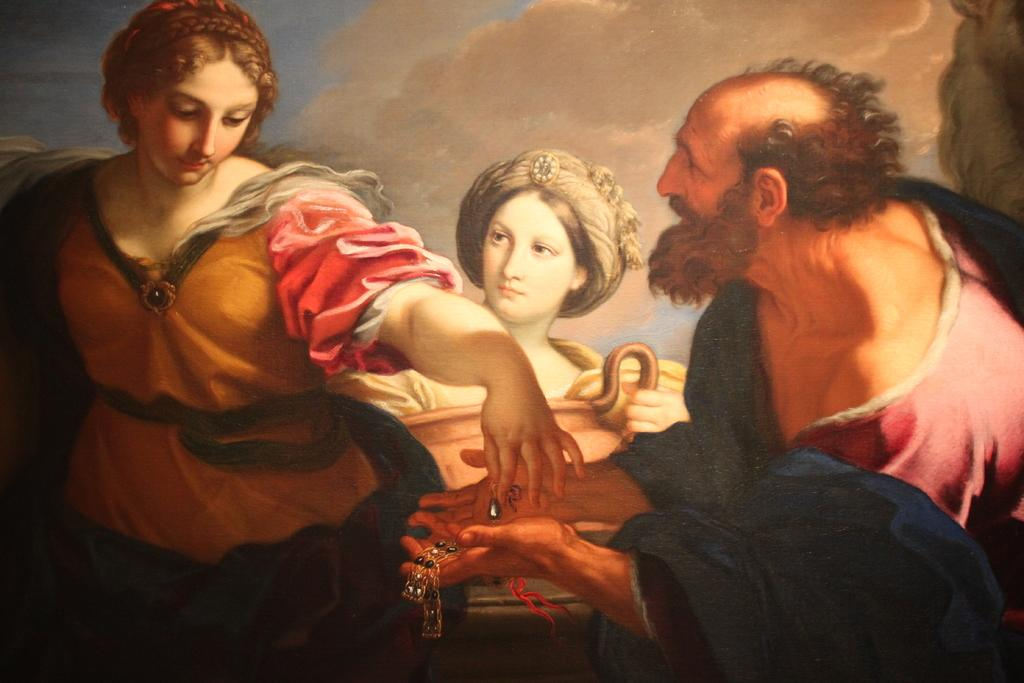Who or what can be seen in the image? There are people in the image. What part of the natural environment is visible in the image? The sky is visible in the image. What type of bell can be heard ringing in the image? There is no bell present in the image, and therefore no sound can be heard. 